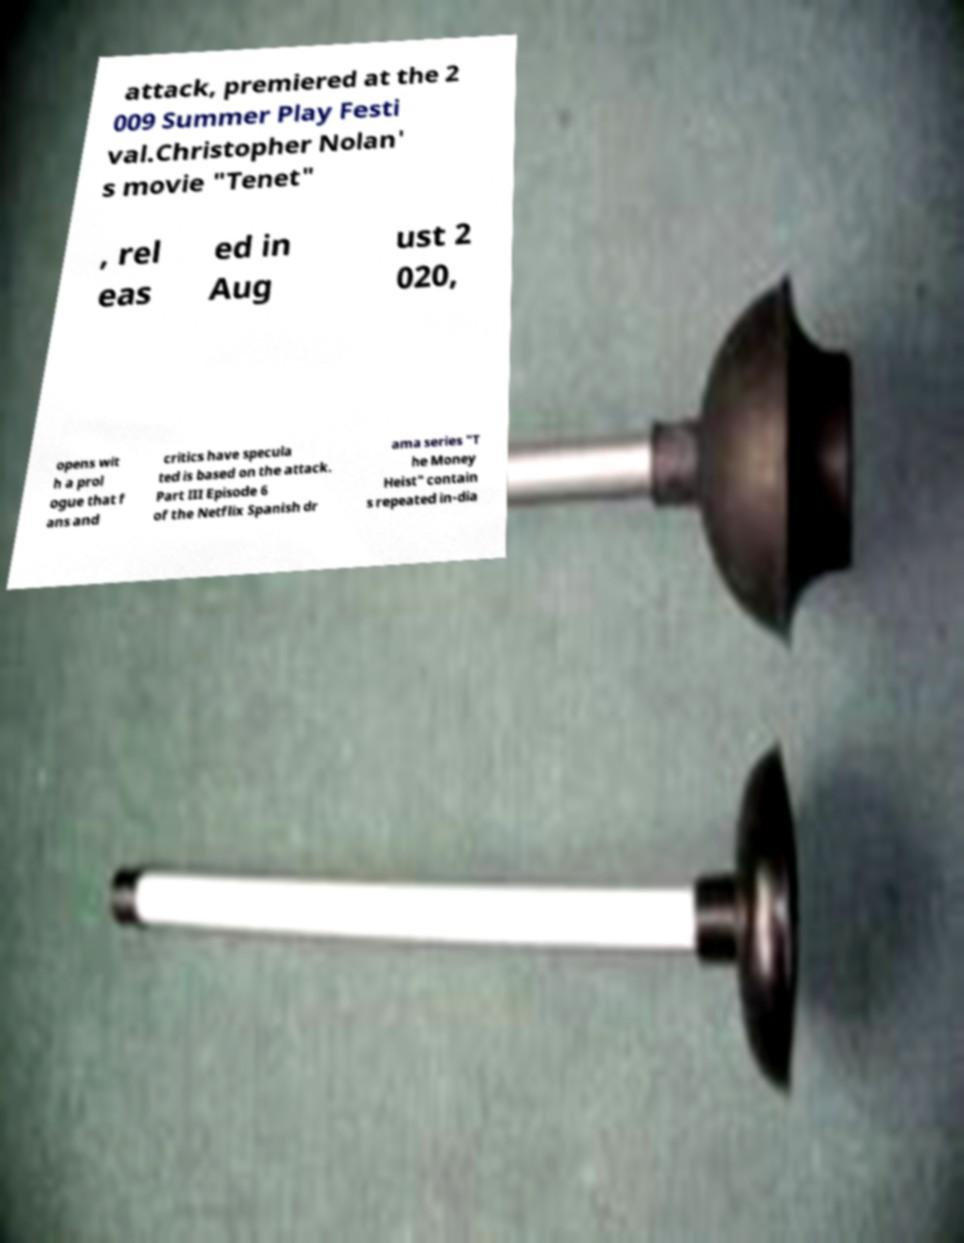Could you assist in decoding the text presented in this image and type it out clearly? attack, premiered at the 2 009 Summer Play Festi val.Christopher Nolan' s movie "Tenet" , rel eas ed in Aug ust 2 020, opens wit h a prol ogue that f ans and critics have specula ted is based on the attack. Part III Episode 6 of the Netflix Spanish dr ama series "T he Money Heist" contain s repeated in-dia 